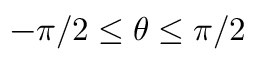Convert formula to latex. <formula><loc_0><loc_0><loc_500><loc_500>- \pi / 2 \leq \theta \leq \pi / 2</formula> 